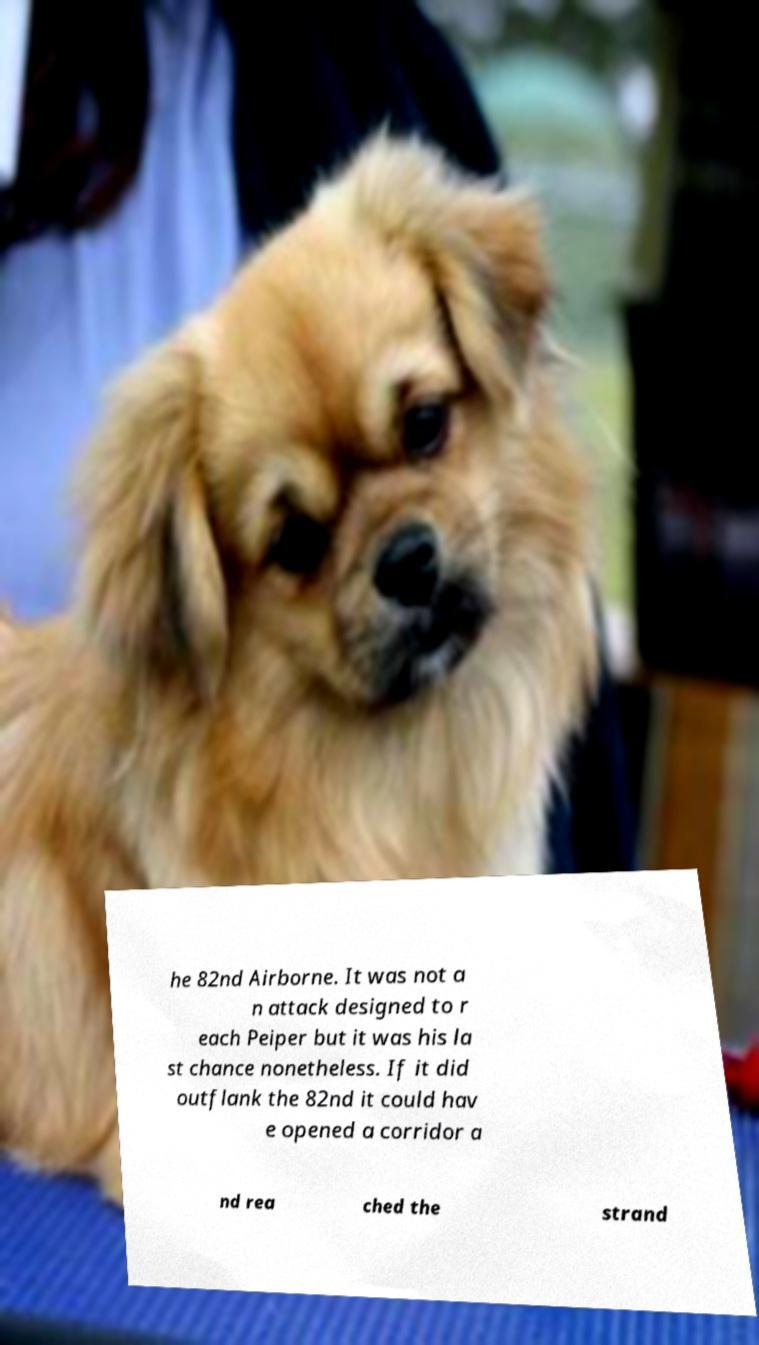Could you extract and type out the text from this image? he 82nd Airborne. It was not a n attack designed to r each Peiper but it was his la st chance nonetheless. If it did outflank the 82nd it could hav e opened a corridor a nd rea ched the strand 